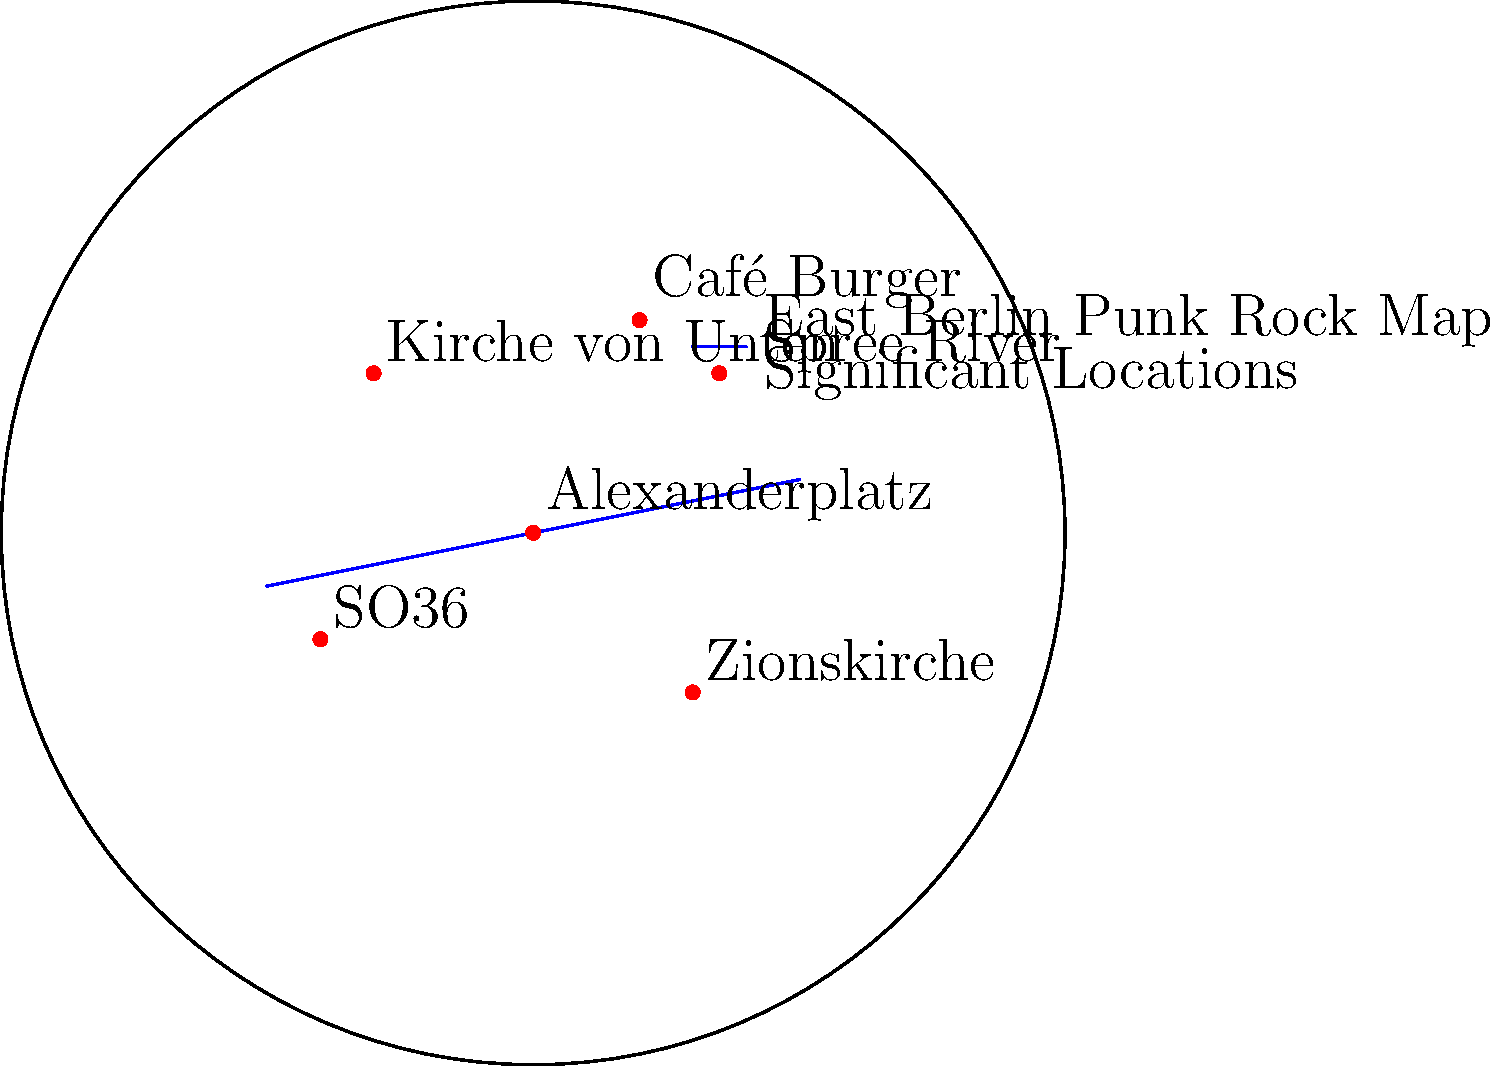Identify the punk rock venue that was closest to Alexanderplatz, a central gathering point for political demonstrations during the late GDR era. How did its location contribute to its significance in the East Berlin punk scene? To answer this question, we need to follow these steps:

1. Identify Alexanderplatz on the map:
   Alexanderplatz is located at the center of the map (0,0).

2. Locate the punk rock venues on the map:
   - Kirche von Unten (-30,30)
   - Café Burger (20,40)
   - SO36 (-40,-20)
   - Zionskirche (30,-30)

3. Determine which venue is closest to Alexanderplatz:
   By visual inspection, SO36 appears to be the closest to Alexanderplatz.

4. Understand the significance of SO36's location:
   - SO36 was located in Kreuzberg, a neighborhood known for its alternative scene and proximity to the Berlin Wall.
   - Its location near Alexanderplatz made it easily accessible for punks and dissidents gathering for demonstrations.
   - The venue could quickly transform from a music space to a meeting point for political activities.
   - Its proximity to the city center increased visibility and impact of punk events and protests.
   - The location allowed for a mix of subcultures and political activists, fostering a diverse and dynamic resistance movement.

5. Contextualize SO36's role in the East Berlin punk scene:
   - SO36 became a symbol of punk's defiance against the GDR regime.
   - Its central location made it a crucial hub for information exchange and organization of underground activities.
   - The venue's events often blurred the lines between musical performances and political statements.
   - Its endurance as a punk venue in a politically sensitive area demonstrated the resilience of the East Berlin punk movement.
Answer: SO36; central location fostered political activism and subcultural convergence. 